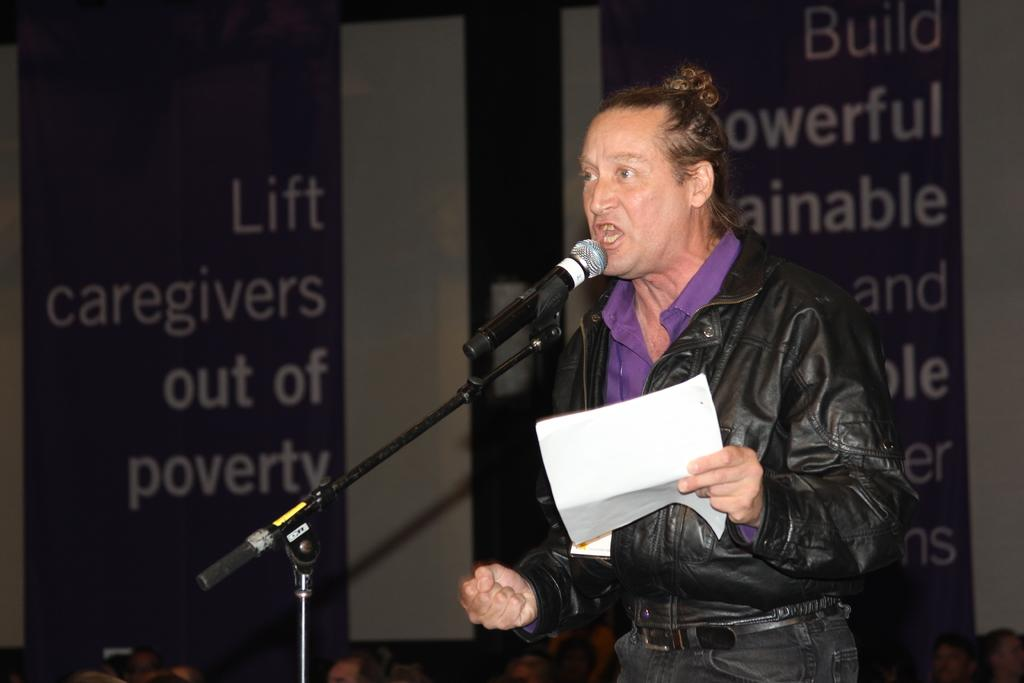Who is the main subject in the image? There is a man in the image. What is the man holding in his hand? The man is holding a paper in his hand. What object is in front of the man? There is a microphone (mic) in front of the man. What can be seen in the background of the image? There are posters and a group of people in the background of the image. What type of car is the man driving in the image? There is no car present in the image; it features a man holding a paper with a microphone in front of him and a group of people in the background. 